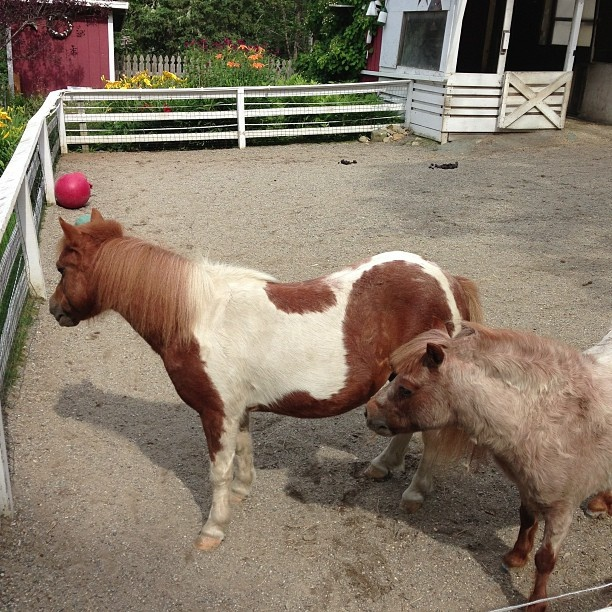Describe the objects in this image and their specific colors. I can see horse in black, maroon, beige, gray, and tan tones, horse in black, gray, tan, and maroon tones, and sports ball in black, brown, and salmon tones in this image. 